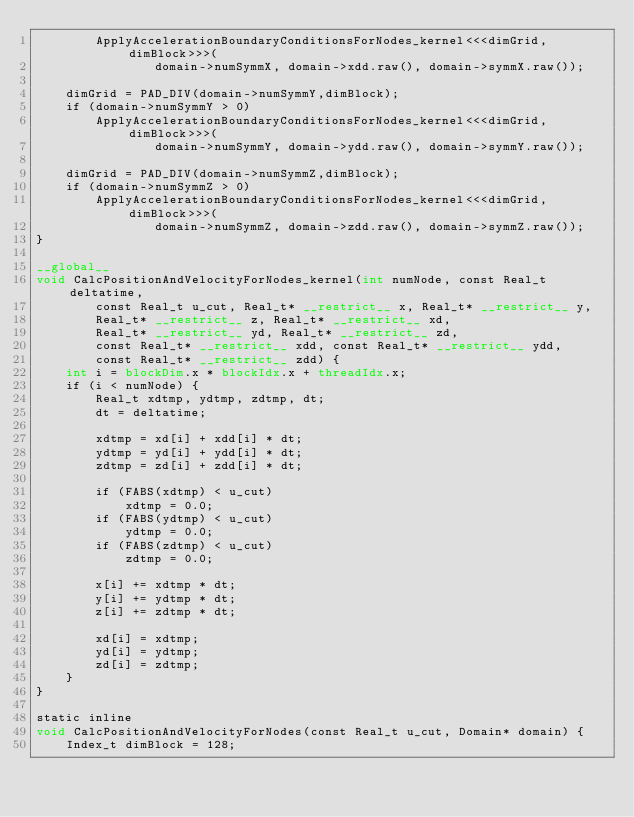<code> <loc_0><loc_0><loc_500><loc_500><_Cuda_>		ApplyAccelerationBoundaryConditionsForNodes_kernel<<<dimGrid, dimBlock>>>(
				domain->numSymmX, domain->xdd.raw(), domain->symmX.raw());

	dimGrid = PAD_DIV(domain->numSymmY,dimBlock);
	if (domain->numSymmY > 0)
		ApplyAccelerationBoundaryConditionsForNodes_kernel<<<dimGrid, dimBlock>>>(
				domain->numSymmY, domain->ydd.raw(), domain->symmY.raw());

	dimGrid = PAD_DIV(domain->numSymmZ,dimBlock);
	if (domain->numSymmZ > 0)
		ApplyAccelerationBoundaryConditionsForNodes_kernel<<<dimGrid, dimBlock>>>(
				domain->numSymmZ, domain->zdd.raw(), domain->symmZ.raw());
}

__global__
void CalcPositionAndVelocityForNodes_kernel(int numNode, const Real_t deltatime,
		const Real_t u_cut, Real_t* __restrict__ x, Real_t* __restrict__ y,
		Real_t* __restrict__ z, Real_t* __restrict__ xd,
		Real_t* __restrict__ yd, Real_t* __restrict__ zd,
		const Real_t* __restrict__ xdd, const Real_t* __restrict__ ydd,
		const Real_t* __restrict__ zdd) {
	int i = blockDim.x * blockIdx.x + threadIdx.x;
	if (i < numNode) {
		Real_t xdtmp, ydtmp, zdtmp, dt;
		dt = deltatime;

		xdtmp = xd[i] + xdd[i] * dt;
		ydtmp = yd[i] + ydd[i] * dt;
		zdtmp = zd[i] + zdd[i] * dt;

		if (FABS(xdtmp) < u_cut)
			xdtmp = 0.0;
		if (FABS(ydtmp) < u_cut)
			ydtmp = 0.0;
		if (FABS(zdtmp) < u_cut)
			zdtmp = 0.0;

		x[i] += xdtmp * dt;
		y[i] += ydtmp * dt;
		z[i] += zdtmp * dt;

		xd[i] = xdtmp;
		yd[i] = ydtmp;
		zd[i] = zdtmp;
	}
}

static inline
void CalcPositionAndVelocityForNodes(const Real_t u_cut, Domain* domain) {
	Index_t dimBlock = 128;</code> 